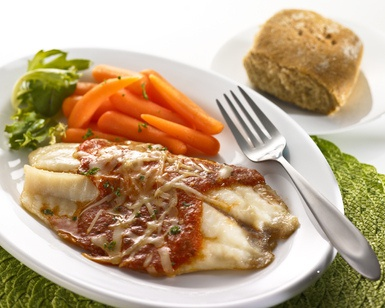Describe the objects in this image and their specific colors. I can see bowl in white, lightgray, brown, olive, and tan tones, carrot in white, red, brown, and orange tones, and fork in white, darkgray, gray, and lightgray tones in this image. 